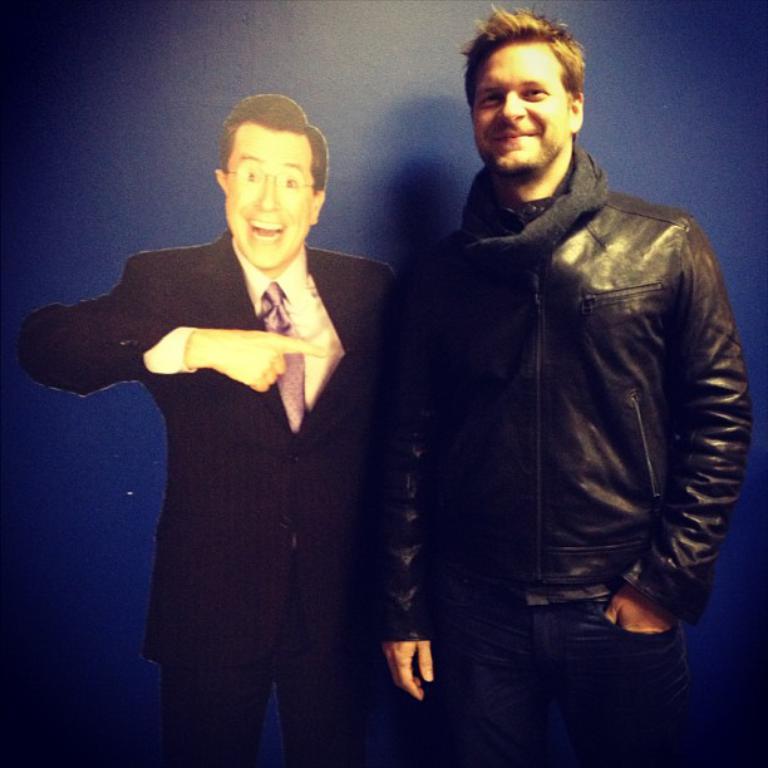Describe this image in one or two sentences. In this image, we can see a person is standing near the blue color board. He is watching and smiling. Beside him, there is a poster on the blue color object. He is a suit, watching and smiling. 